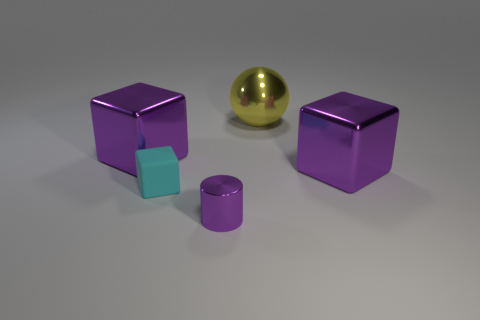Add 1 matte objects. How many objects exist? 6 Subtract all cubes. How many objects are left? 2 Add 3 large cubes. How many large cubes exist? 5 Subtract 1 cyan blocks. How many objects are left? 4 Subtract all big things. Subtract all purple shiny cylinders. How many objects are left? 1 Add 5 large cubes. How many large cubes are left? 7 